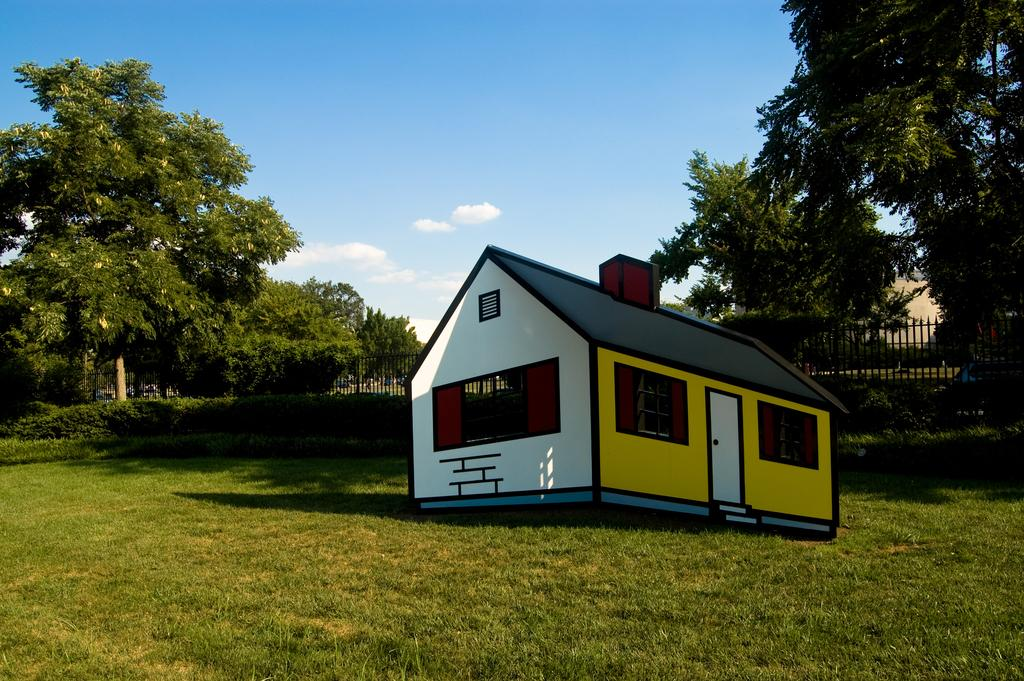What type of structure is present in the image? There is a house in the image. What type of vegetation can be seen in the image? There is grass, plants, and trees in the image. What type of barrier is present in the image? There is a fence in the image. What is visible in the background of the image? The sky is visible in the background of the image. What can be seen in the sky? There are clouds in the sky. How does the paste help in transporting the army in the image? There is no paste, transport, or army present in the image. 